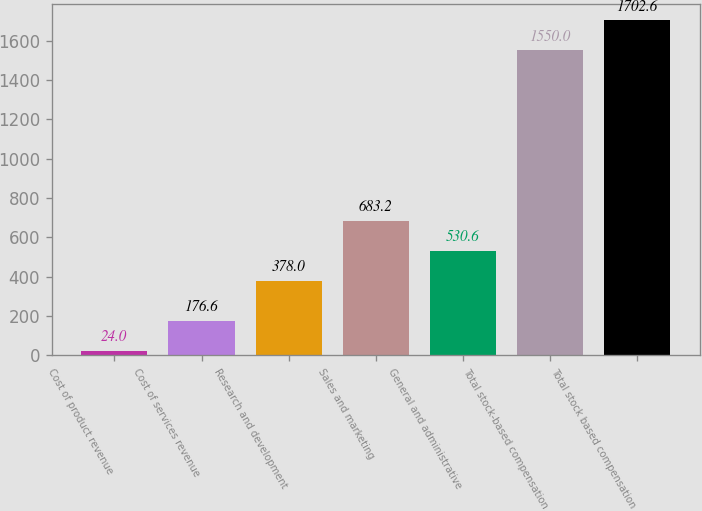Convert chart to OTSL. <chart><loc_0><loc_0><loc_500><loc_500><bar_chart><fcel>Cost of product revenue<fcel>Cost of services revenue<fcel>Research and development<fcel>Sales and marketing<fcel>General and administrative<fcel>Total stock-based compensation<fcel>Total stock based compensation<nl><fcel>24<fcel>176.6<fcel>378<fcel>683.2<fcel>530.6<fcel>1550<fcel>1702.6<nl></chart> 